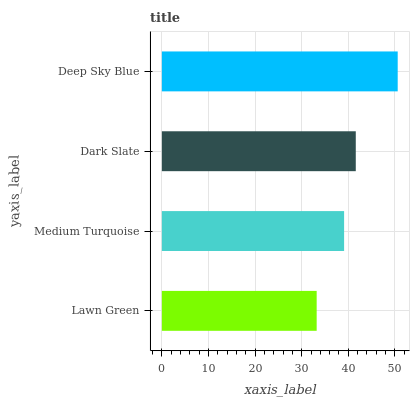Is Lawn Green the minimum?
Answer yes or no. Yes. Is Deep Sky Blue the maximum?
Answer yes or no. Yes. Is Medium Turquoise the minimum?
Answer yes or no. No. Is Medium Turquoise the maximum?
Answer yes or no. No. Is Medium Turquoise greater than Lawn Green?
Answer yes or no. Yes. Is Lawn Green less than Medium Turquoise?
Answer yes or no. Yes. Is Lawn Green greater than Medium Turquoise?
Answer yes or no. No. Is Medium Turquoise less than Lawn Green?
Answer yes or no. No. Is Dark Slate the high median?
Answer yes or no. Yes. Is Medium Turquoise the low median?
Answer yes or no. Yes. Is Lawn Green the high median?
Answer yes or no. No. Is Lawn Green the low median?
Answer yes or no. No. 